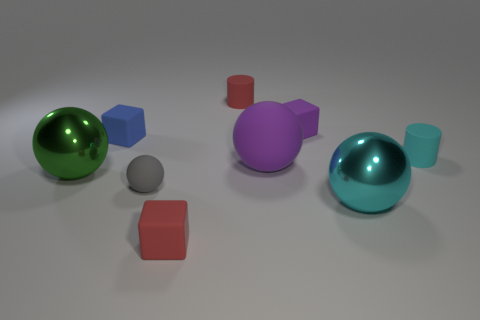How many other objects are there of the same color as the large rubber ball?
Ensure brevity in your answer.  1. What number of big rubber things are there?
Offer a very short reply. 1. There is a big thing that is to the left of the cube in front of the large purple sphere; what is it made of?
Your response must be concise. Metal. There is a green thing that is the same size as the cyan ball; what material is it?
Ensure brevity in your answer.  Metal. There is a thing in front of the cyan sphere; is its size the same as the blue block?
Provide a short and direct response. Yes. Do the small red object in front of the tiny cyan matte cylinder and the green metal object have the same shape?
Keep it short and to the point. No. What number of objects are either large cyan things or red things in front of the cyan matte cylinder?
Provide a short and direct response. 2. Are there fewer cyan rubber cylinders than tiny blocks?
Your response must be concise. Yes. Are there more red matte cylinders than tiny blue metal cubes?
Your answer should be compact. Yes. How many other objects are the same material as the small sphere?
Your answer should be compact. 6. 